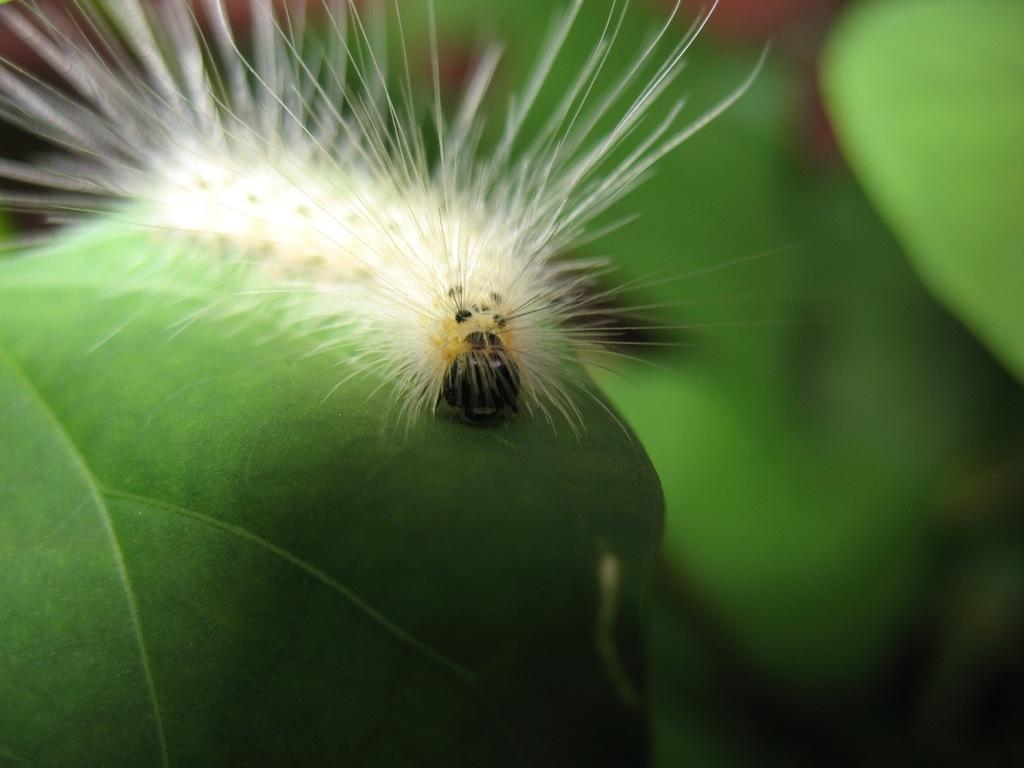What type of animal is in the image? There is an earthworm in the image. Where is the earthworm located? The earthworm is on a leaf. What type of knife is being used by the goldfish in the image? There is no knife or goldfish present in the image; it features an earthworm on a leaf. 